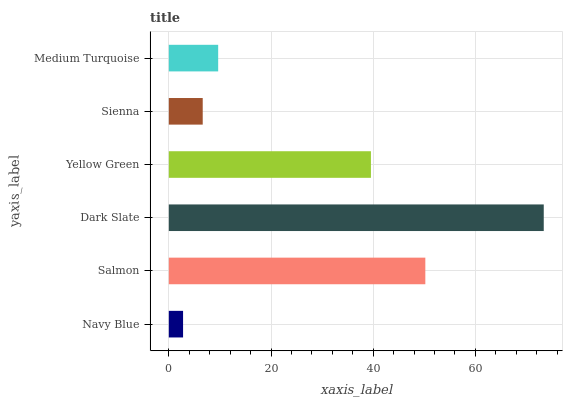Is Navy Blue the minimum?
Answer yes or no. Yes. Is Dark Slate the maximum?
Answer yes or no. Yes. Is Salmon the minimum?
Answer yes or no. No. Is Salmon the maximum?
Answer yes or no. No. Is Salmon greater than Navy Blue?
Answer yes or no. Yes. Is Navy Blue less than Salmon?
Answer yes or no. Yes. Is Navy Blue greater than Salmon?
Answer yes or no. No. Is Salmon less than Navy Blue?
Answer yes or no. No. Is Yellow Green the high median?
Answer yes or no. Yes. Is Medium Turquoise the low median?
Answer yes or no. Yes. Is Medium Turquoise the high median?
Answer yes or no. No. Is Yellow Green the low median?
Answer yes or no. No. 